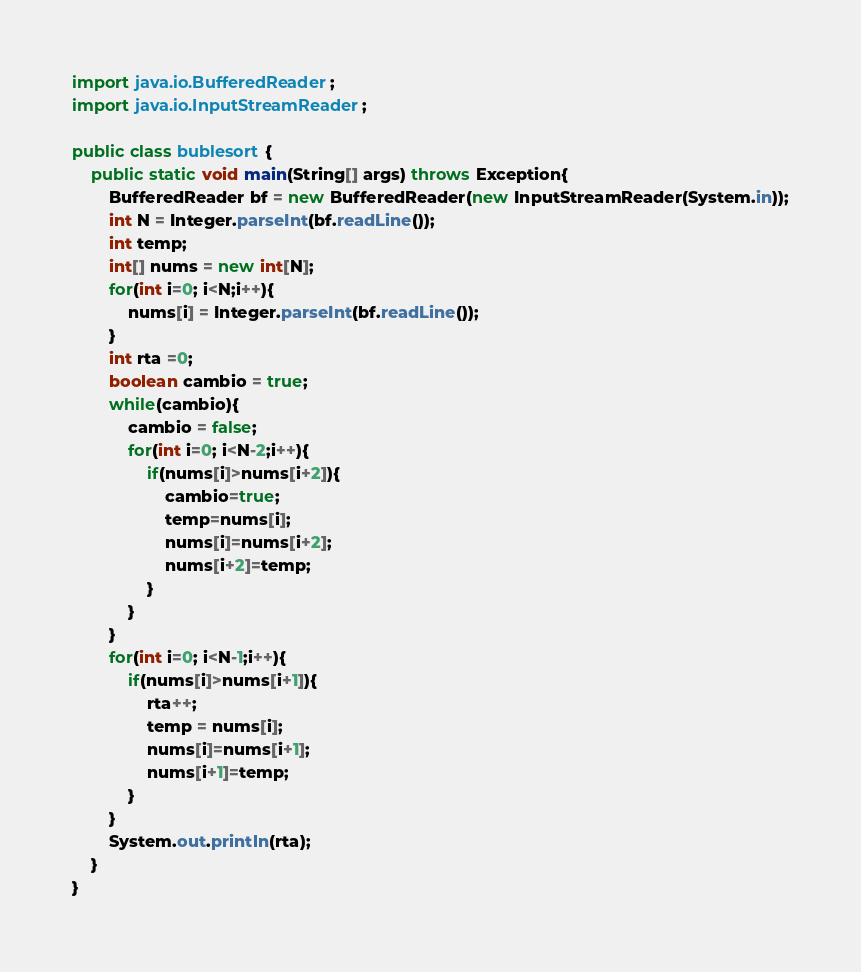<code> <loc_0><loc_0><loc_500><loc_500><_Java_>import java.io.BufferedReader;
import java.io.InputStreamReader;

public class bublesort {
	public static void main(String[] args) throws Exception{
		BufferedReader bf = new BufferedReader(new InputStreamReader(System.in));
		int N = Integer.parseInt(bf.readLine());
		int temp;
		int[] nums = new int[N];
		for(int i=0; i<N;i++){
			nums[i] = Integer.parseInt(bf.readLine());
		}
		int rta =0;
		boolean cambio = true;
		while(cambio){
			cambio = false;
			for(int i=0; i<N-2;i++){
				if(nums[i]>nums[i+2]){
					cambio=true;
					temp=nums[i];
					nums[i]=nums[i+2];
					nums[i+2]=temp;
				}
			}
		}
		for(int i=0; i<N-1;i++){
			if(nums[i]>nums[i+1]){
				rta++;
				temp = nums[i];
				nums[i]=nums[i+1];
				nums[i+1]=temp;
			}
		}
		System.out.println(rta);
	}
}
</code> 